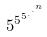<formula> <loc_0><loc_0><loc_500><loc_500>5 ^ { 5 ^ { 5 ^ { . ^ { . ^ { n } } } } }</formula> 